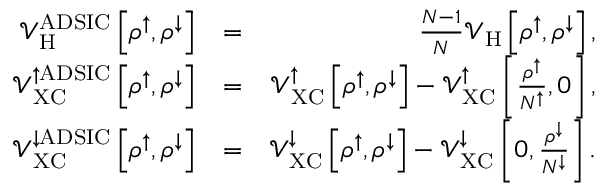Convert formula to latex. <formula><loc_0><loc_0><loc_500><loc_500>\begin{array} { r l r } { \mathcal { V } _ { H } ^ { A D S I C } \left [ \rho ^ { \uparrow } , \rho ^ { \downarrow } \right ] } & { = } & { \frac { N - 1 } { N } \mathcal { V } _ { H } \left [ \rho ^ { \uparrow } , \rho ^ { \downarrow } \right ] , } \\ { \mathcal { V } _ { X C } ^ { \uparrow A D S I C } \left [ \rho ^ { \uparrow } , \rho ^ { \downarrow } \right ] } & { = } & { \mathcal { V } _ { X C } ^ { \uparrow } \left [ \rho ^ { \uparrow } , \rho ^ { \downarrow } \right ] - \mathcal { V } _ { X C } ^ { \uparrow } \left [ \frac { \rho ^ { \uparrow } } { N ^ { \uparrow } } , 0 \right ] , } \\ { \mathcal { V } _ { X C } ^ { \downarrow A D S I C } \left [ \rho ^ { \uparrow } , \rho ^ { \downarrow } \right ] } & { = } & { \mathcal { V } _ { X C } ^ { \downarrow } \left [ \rho ^ { \uparrow } , \rho ^ { \downarrow } \right ] - \mathcal { V } _ { X C } ^ { \downarrow } \left [ 0 , \frac { \rho ^ { \downarrow } } { N ^ { \downarrow } } \right ] . } \end{array}</formula> 